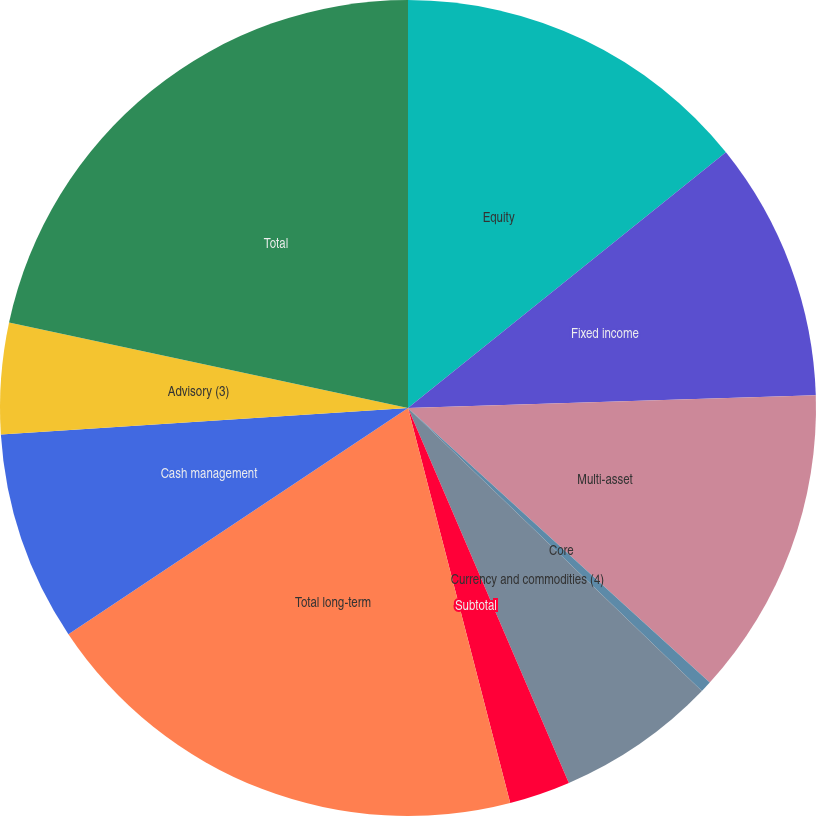Convert chart. <chart><loc_0><loc_0><loc_500><loc_500><pie_chart><fcel>Equity<fcel>Fixed income<fcel>Multi-asset<fcel>Core<fcel>Currency and commodities (4)<fcel>Subtotal<fcel>Total long-term<fcel>Cash management<fcel>Advisory (3)<fcel>Total<nl><fcel>14.22%<fcel>10.28%<fcel>12.25%<fcel>0.45%<fcel>6.35%<fcel>2.42%<fcel>19.68%<fcel>8.32%<fcel>4.39%<fcel>21.64%<nl></chart> 